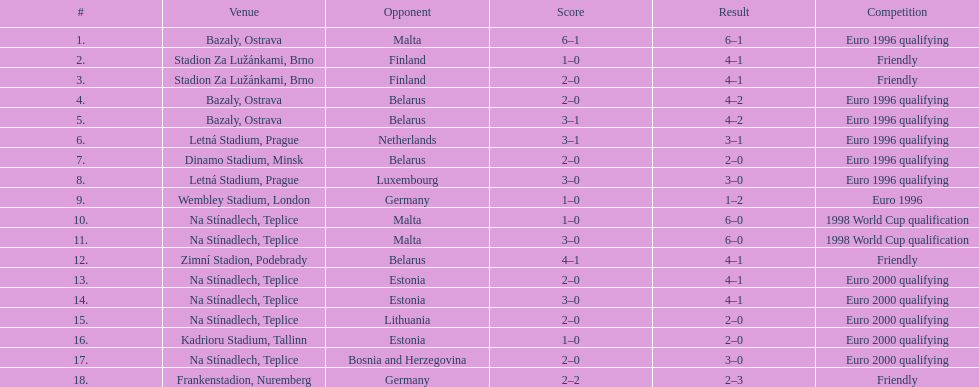How many total games took place in 1999? 3. 